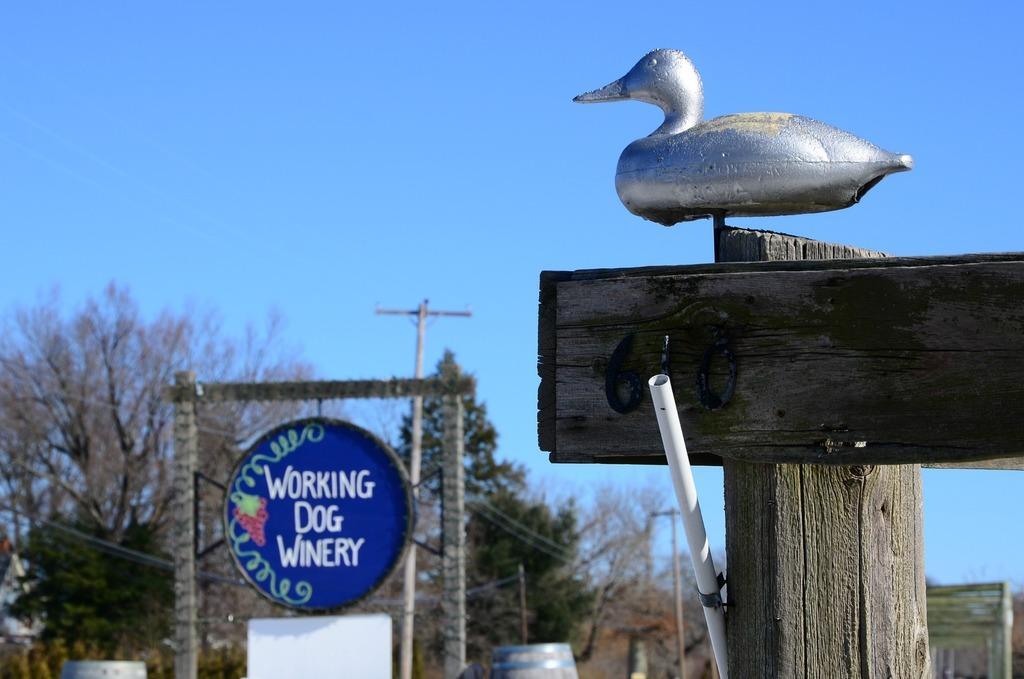Could you give a brief overview of what you see in this image? In the foreground of this picture, there is a duck structure to the wood on the right and there is also a pipe to the wood. In the background, there is a blue board, drums, trees, cables, poles and the sky. 